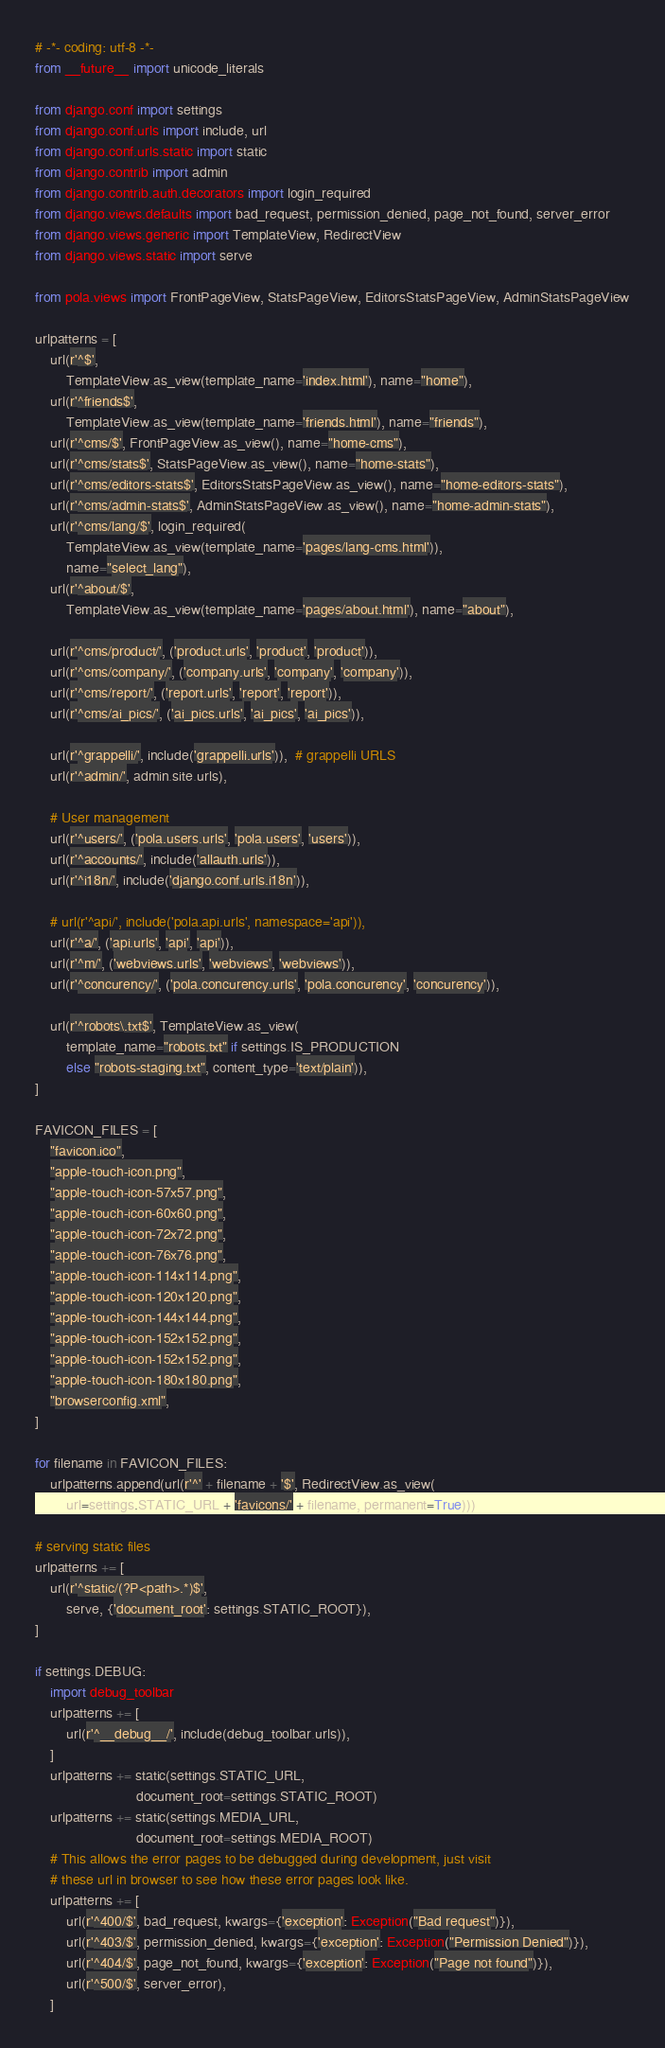Convert code to text. <code><loc_0><loc_0><loc_500><loc_500><_Python_># -*- coding: utf-8 -*-
from __future__ import unicode_literals

from django.conf import settings
from django.conf.urls import include, url
from django.conf.urls.static import static
from django.contrib import admin
from django.contrib.auth.decorators import login_required
from django.views.defaults import bad_request, permission_denied, page_not_found, server_error
from django.views.generic import TemplateView, RedirectView
from django.views.static import serve

from pola.views import FrontPageView, StatsPageView, EditorsStatsPageView, AdminStatsPageView

urlpatterns = [
    url(r'^$',
        TemplateView.as_view(template_name='index.html'), name="home"),
    url(r'^friends$',
        TemplateView.as_view(template_name='friends.html'), name="friends"),
    url(r'^cms/$', FrontPageView.as_view(), name="home-cms"),
    url(r'^cms/stats$', StatsPageView.as_view(), name="home-stats"),
    url(r'^cms/editors-stats$', EditorsStatsPageView.as_view(), name="home-editors-stats"),
    url(r'^cms/admin-stats$', AdminStatsPageView.as_view(), name="home-admin-stats"),
    url(r'^cms/lang/$', login_required(
        TemplateView.as_view(template_name='pages/lang-cms.html')),
        name="select_lang"),
    url(r'^about/$',
        TemplateView.as_view(template_name='pages/about.html'), name="about"),

    url(r'^cms/product/', ('product.urls', 'product', 'product')),
    url(r'^cms/company/', ('company.urls', 'company', 'company')),
    url(r'^cms/report/', ('report.urls', 'report', 'report')),
    url(r'^cms/ai_pics/', ('ai_pics.urls', 'ai_pics', 'ai_pics')),

    url(r'^grappelli/', include('grappelli.urls')),  # grappelli URLS
    url(r'^admin/', admin.site.urls),

    # User management
    url(r'^users/', ('pola.users.urls', 'pola.users', 'users')),
    url(r'^accounts/', include('allauth.urls')),
    url(r'^i18n/', include('django.conf.urls.i18n')),

    # url(r'^api/', include('pola.api.urls', namespace='api')),
    url(r'^a/', ('api.urls', 'api', 'api')),
    url(r'^m/', ('webviews.urls', 'webviews', 'webviews')),
    url(r'^concurency/', ('pola.concurency.urls', 'pola.concurency', 'concurency')),

    url(r'^robots\.txt$', TemplateView.as_view(
        template_name="robots.txt" if settings.IS_PRODUCTION
        else "robots-staging.txt", content_type='text/plain')),
]

FAVICON_FILES = [
    "favicon.ico",
    "apple-touch-icon.png",
    "apple-touch-icon-57x57.png",
    "apple-touch-icon-60x60.png",
    "apple-touch-icon-72x72.png",
    "apple-touch-icon-76x76.png",
    "apple-touch-icon-114x114.png",
    "apple-touch-icon-120x120.png",
    "apple-touch-icon-144x144.png",
    "apple-touch-icon-152x152.png",
    "apple-touch-icon-152x152.png",
    "apple-touch-icon-180x180.png",
    "browserconfig.xml",
]

for filename in FAVICON_FILES:
    urlpatterns.append(url(r'^' + filename + '$', RedirectView.as_view(
        url=settings.STATIC_URL + 'favicons/' + filename, permanent=True)))

# serving static files
urlpatterns += [
    url(r'^static/(?P<path>.*)$',
        serve, {'document_root': settings.STATIC_ROOT}),
]

if settings.DEBUG:
    import debug_toolbar
    urlpatterns += [
        url(r'^__debug__/', include(debug_toolbar.urls)),
    ]
    urlpatterns += static(settings.STATIC_URL,
                          document_root=settings.STATIC_ROOT)
    urlpatterns += static(settings.MEDIA_URL,
                          document_root=settings.MEDIA_ROOT)
    # This allows the error pages to be debugged during development, just visit
    # these url in browser to see how these error pages look like.
    urlpatterns += [
        url(r'^400/$', bad_request, kwargs={'exception': Exception("Bad request")}),
        url(r'^403/$', permission_denied, kwargs={'exception': Exception("Permission Denied")}),
        url(r'^404/$', page_not_found, kwargs={'exception': Exception("Page not found")}),
        url(r'^500/$', server_error),
    ]
</code> 